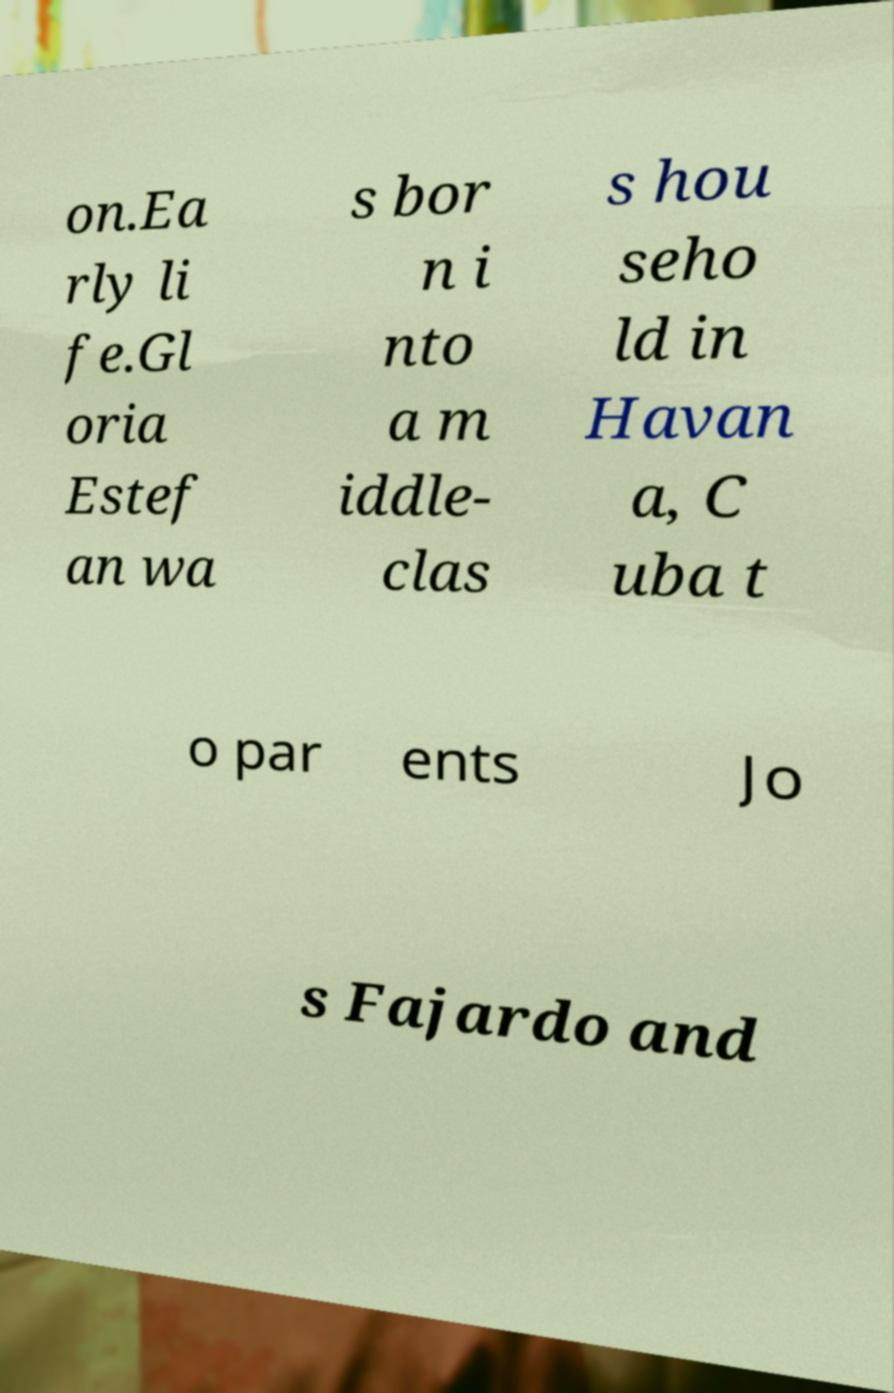Can you read and provide the text displayed in the image?This photo seems to have some interesting text. Can you extract and type it out for me? on.Ea rly li fe.Gl oria Estef an wa s bor n i nto a m iddle- clas s hou seho ld in Havan a, C uba t o par ents Jo s Fajardo and 